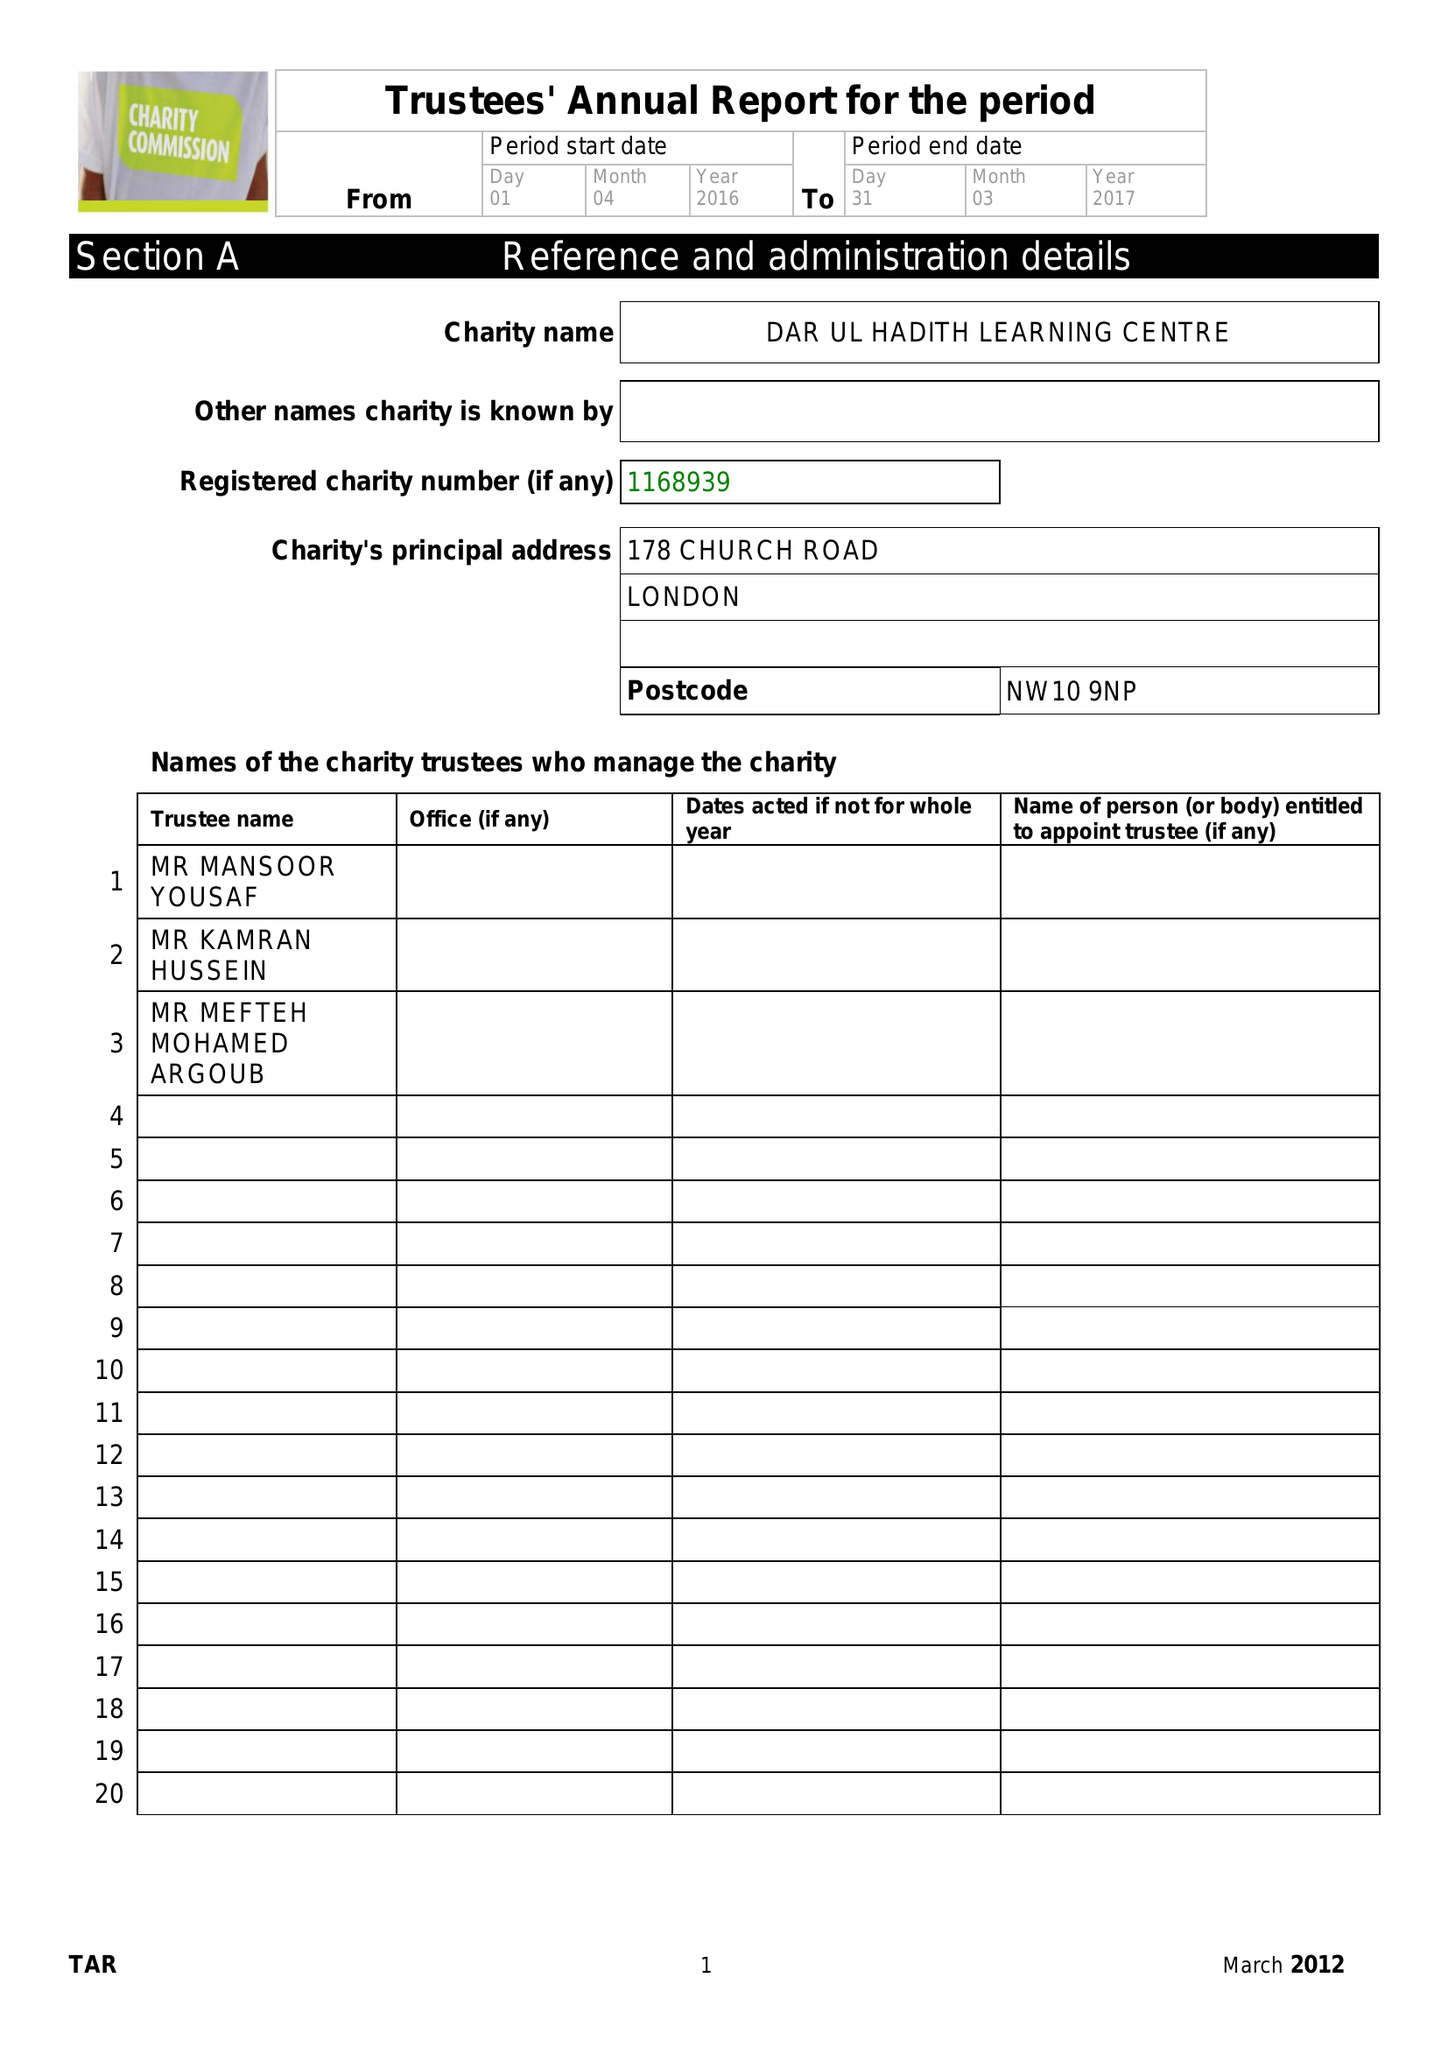What is the value for the charity_name?
Answer the question using a single word or phrase. Dar Ul Hadith Learning Centre 